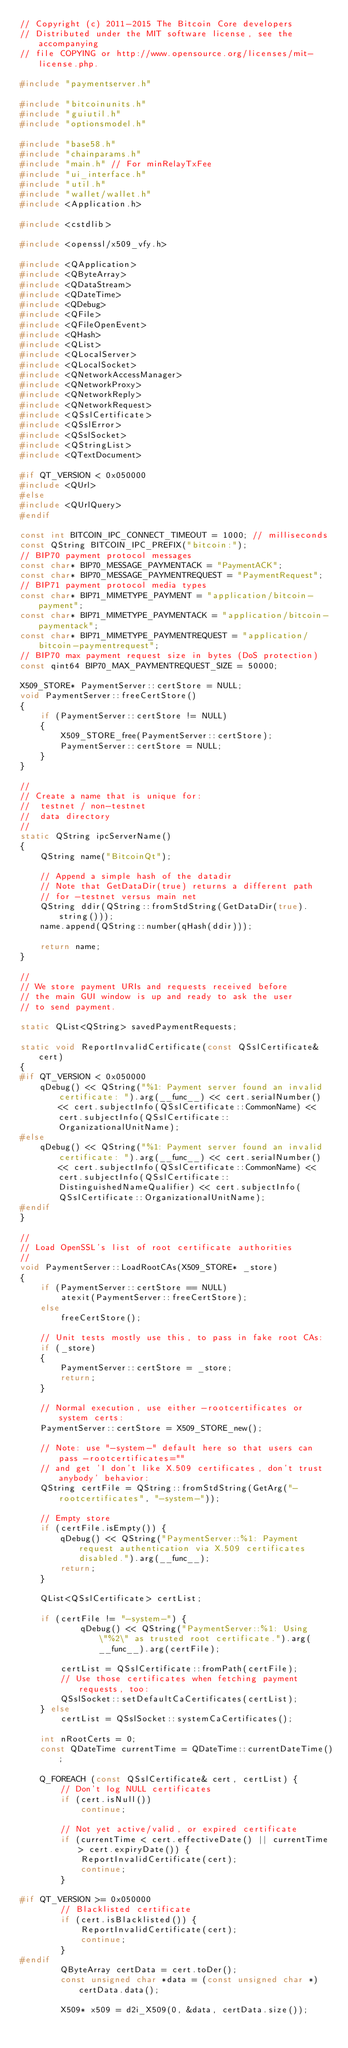Convert code to text. <code><loc_0><loc_0><loc_500><loc_500><_C++_>// Copyright (c) 2011-2015 The Bitcoin Core developers
// Distributed under the MIT software license, see the accompanying
// file COPYING or http://www.opensource.org/licenses/mit-license.php.

#include "paymentserver.h"

#include "bitcoinunits.h"
#include "guiutil.h"
#include "optionsmodel.h"

#include "base58.h"
#include "chainparams.h"
#include "main.h" // For minRelayTxFee
#include "ui_interface.h"
#include "util.h"
#include "wallet/wallet.h"
#include <Application.h>

#include <cstdlib>

#include <openssl/x509_vfy.h>

#include <QApplication>
#include <QByteArray>
#include <QDataStream>
#include <QDateTime>
#include <QDebug>
#include <QFile>
#include <QFileOpenEvent>
#include <QHash>
#include <QList>
#include <QLocalServer>
#include <QLocalSocket>
#include <QNetworkAccessManager>
#include <QNetworkProxy>
#include <QNetworkReply>
#include <QNetworkRequest>
#include <QSslCertificate>
#include <QSslError>
#include <QSslSocket>
#include <QStringList>
#include <QTextDocument>

#if QT_VERSION < 0x050000
#include <QUrl>
#else
#include <QUrlQuery>
#endif

const int BITCOIN_IPC_CONNECT_TIMEOUT = 1000; // milliseconds
const QString BITCOIN_IPC_PREFIX("bitcoin:");
// BIP70 payment protocol messages
const char* BIP70_MESSAGE_PAYMENTACK = "PaymentACK";
const char* BIP70_MESSAGE_PAYMENTREQUEST = "PaymentRequest";
// BIP71 payment protocol media types
const char* BIP71_MIMETYPE_PAYMENT = "application/bitcoin-payment";
const char* BIP71_MIMETYPE_PAYMENTACK = "application/bitcoin-paymentack";
const char* BIP71_MIMETYPE_PAYMENTREQUEST = "application/bitcoin-paymentrequest";
// BIP70 max payment request size in bytes (DoS protection)
const qint64 BIP70_MAX_PAYMENTREQUEST_SIZE = 50000;

X509_STORE* PaymentServer::certStore = NULL;
void PaymentServer::freeCertStore()
{
    if (PaymentServer::certStore != NULL)
    {
        X509_STORE_free(PaymentServer::certStore);
        PaymentServer::certStore = NULL;
    }
}

//
// Create a name that is unique for:
//  testnet / non-testnet
//  data directory
//
static QString ipcServerName()
{
    QString name("BitcoinQt");

    // Append a simple hash of the datadir
    // Note that GetDataDir(true) returns a different path
    // for -testnet versus main net
    QString ddir(QString::fromStdString(GetDataDir(true).string()));
    name.append(QString::number(qHash(ddir)));

    return name;
}

//
// We store payment URIs and requests received before
// the main GUI window is up and ready to ask the user
// to send payment.

static QList<QString> savedPaymentRequests;

static void ReportInvalidCertificate(const QSslCertificate& cert)
{
#if QT_VERSION < 0x050000
    qDebug() << QString("%1: Payment server found an invalid certificate: ").arg(__func__) << cert.serialNumber() << cert.subjectInfo(QSslCertificate::CommonName) << cert.subjectInfo(QSslCertificate::OrganizationalUnitName);
#else
    qDebug() << QString("%1: Payment server found an invalid certificate: ").arg(__func__) << cert.serialNumber() << cert.subjectInfo(QSslCertificate::CommonName) << cert.subjectInfo(QSslCertificate::DistinguishedNameQualifier) << cert.subjectInfo(QSslCertificate::OrganizationalUnitName);
#endif
}

//
// Load OpenSSL's list of root certificate authorities
//
void PaymentServer::LoadRootCAs(X509_STORE* _store)
{
    if (PaymentServer::certStore == NULL)
        atexit(PaymentServer::freeCertStore);
    else
        freeCertStore();

    // Unit tests mostly use this, to pass in fake root CAs:
    if (_store)
    {
        PaymentServer::certStore = _store;
        return;
    }

    // Normal execution, use either -rootcertificates or system certs:
    PaymentServer::certStore = X509_STORE_new();

    // Note: use "-system-" default here so that users can pass -rootcertificates=""
    // and get 'I don't like X.509 certificates, don't trust anybody' behavior:
    QString certFile = QString::fromStdString(GetArg("-rootcertificates", "-system-"));

    // Empty store
    if (certFile.isEmpty()) {
        qDebug() << QString("PaymentServer::%1: Payment request authentication via X.509 certificates disabled.").arg(__func__);
        return;
    }

    QList<QSslCertificate> certList;

    if (certFile != "-system-") {
            qDebug() << QString("PaymentServer::%1: Using \"%2\" as trusted root certificate.").arg(__func__).arg(certFile);

        certList = QSslCertificate::fromPath(certFile);
        // Use those certificates when fetching payment requests, too:
        QSslSocket::setDefaultCaCertificates(certList);
    } else
        certList = QSslSocket::systemCaCertificates();

    int nRootCerts = 0;
    const QDateTime currentTime = QDateTime::currentDateTime();

    Q_FOREACH (const QSslCertificate& cert, certList) {
        // Don't log NULL certificates
        if (cert.isNull())
            continue;

        // Not yet active/valid, or expired certificate
        if (currentTime < cert.effectiveDate() || currentTime > cert.expiryDate()) {
            ReportInvalidCertificate(cert);
            continue;
        }

#if QT_VERSION >= 0x050000
        // Blacklisted certificate
        if (cert.isBlacklisted()) {
            ReportInvalidCertificate(cert);
            continue;
        }
#endif
        QByteArray certData = cert.toDer();
        const unsigned char *data = (const unsigned char *)certData.data();

        X509* x509 = d2i_X509(0, &data, certData.size());</code> 